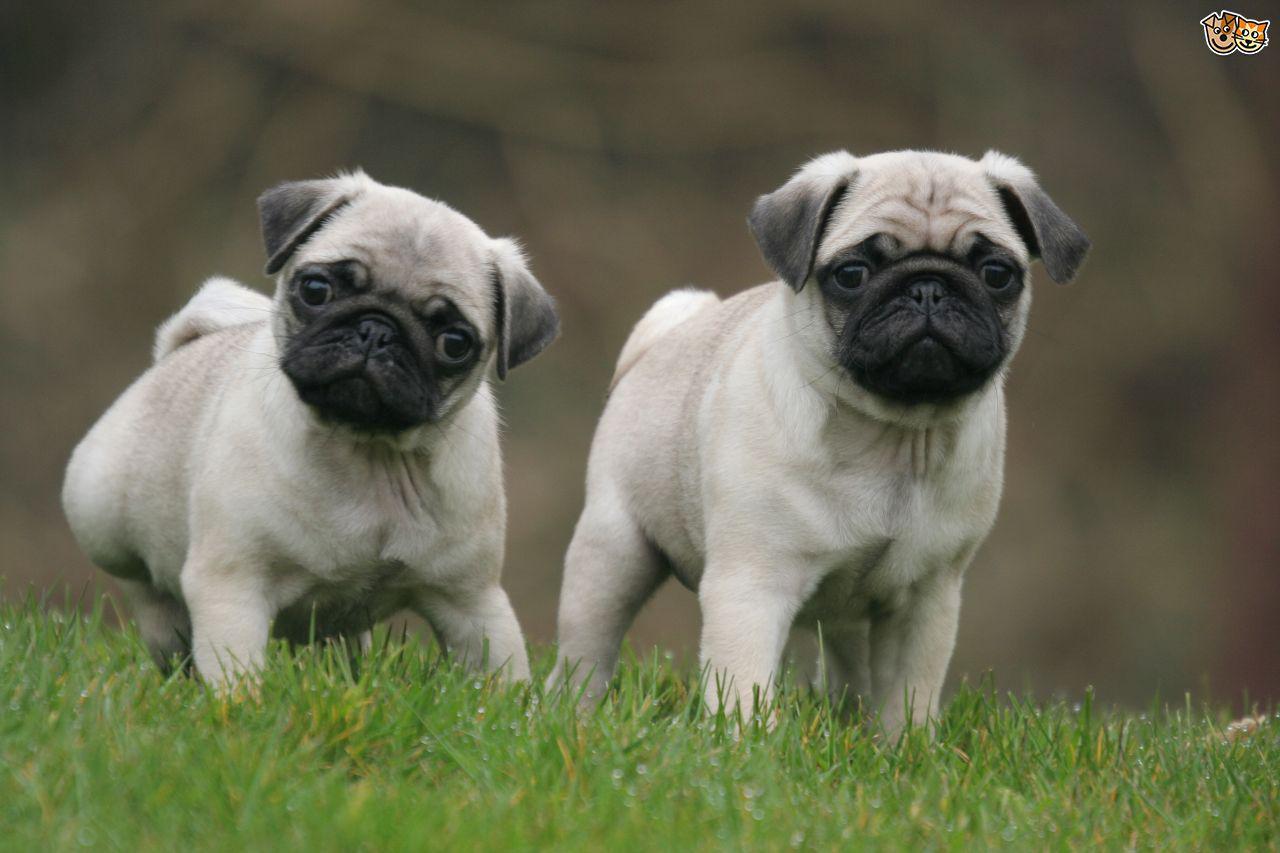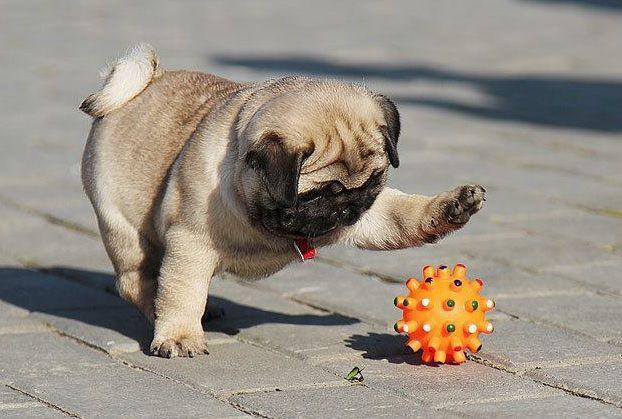The first image is the image on the left, the second image is the image on the right. Considering the images on both sides, is "An image shows one pug with a toy ball of some type." valid? Answer yes or no. Yes. The first image is the image on the left, the second image is the image on the right. For the images shown, is this caption "There is no more than one dog in the left image." true? Answer yes or no. No. 